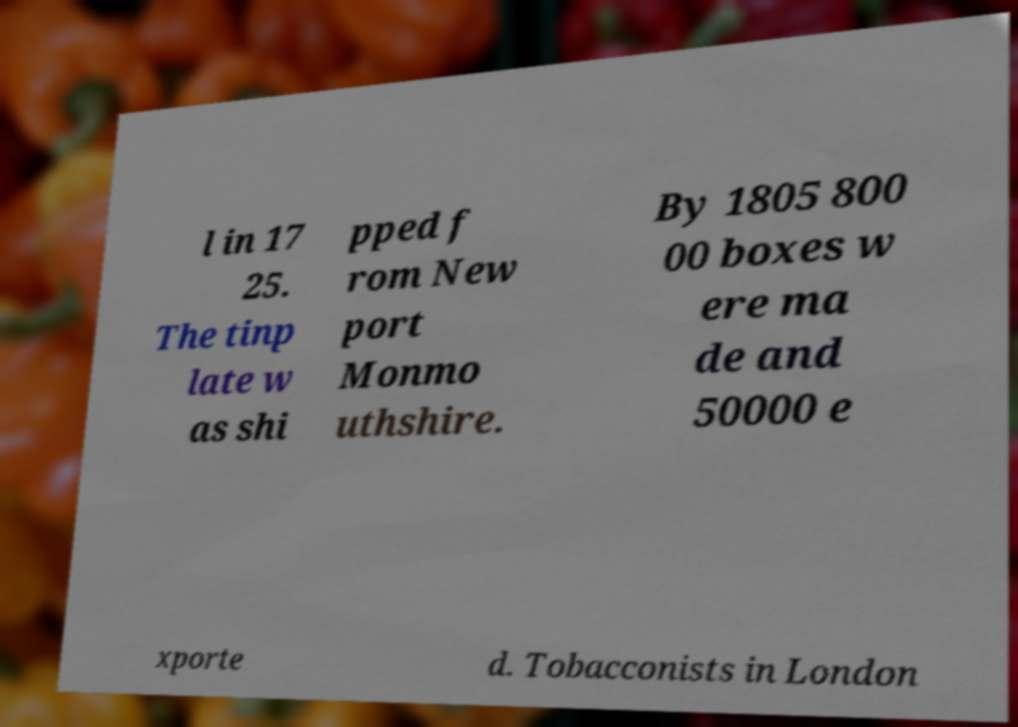I need the written content from this picture converted into text. Can you do that? l in 17 25. The tinp late w as shi pped f rom New port Monmo uthshire. By 1805 800 00 boxes w ere ma de and 50000 e xporte d. Tobacconists in London 